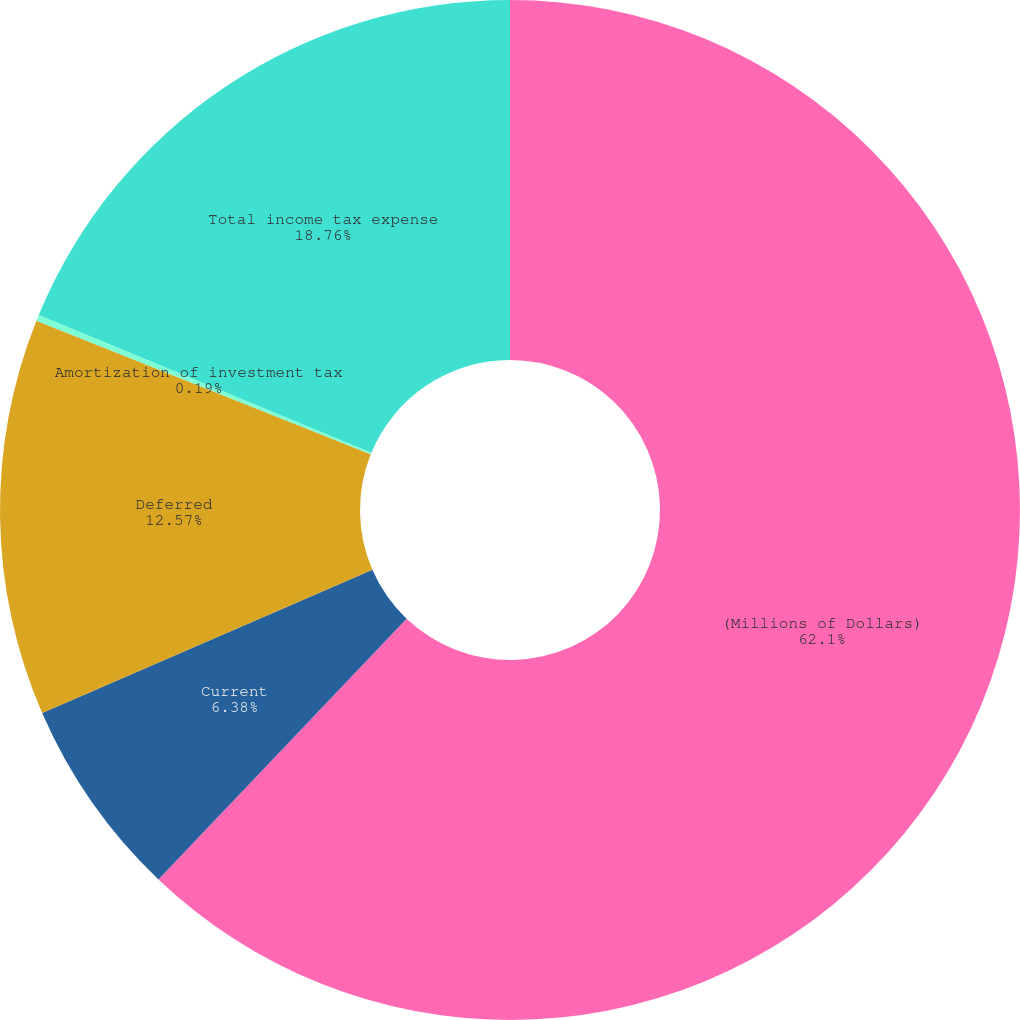<chart> <loc_0><loc_0><loc_500><loc_500><pie_chart><fcel>(Millions of Dollars)<fcel>Current<fcel>Deferred<fcel>Amortization of investment tax<fcel>Total income tax expense<nl><fcel>62.11%<fcel>6.38%<fcel>12.57%<fcel>0.19%<fcel>18.76%<nl></chart> 